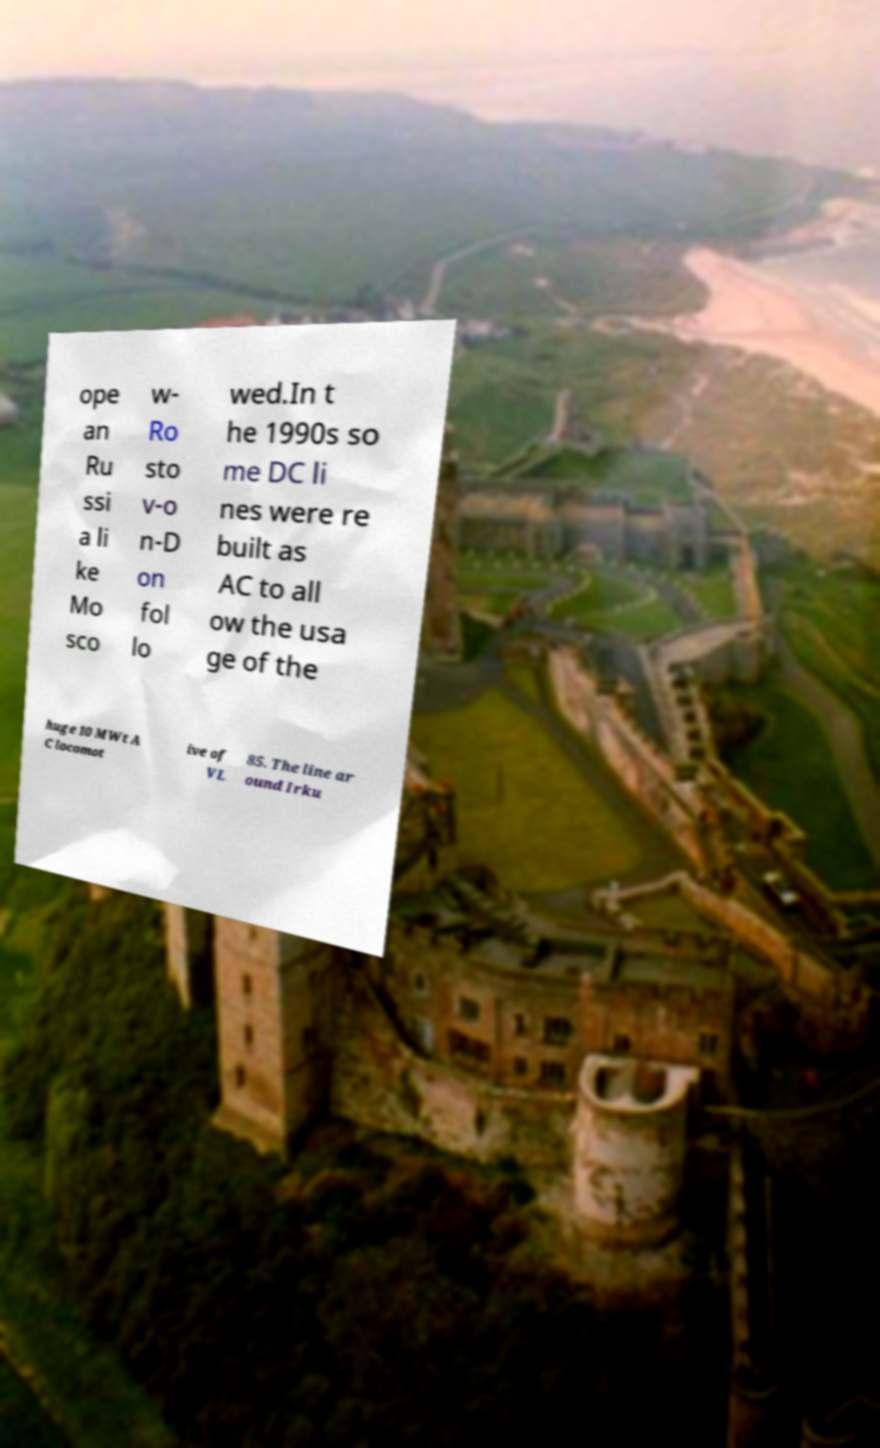Please identify and transcribe the text found in this image. ope an Ru ssi a li ke Mo sco w- Ro sto v-o n-D on fol lo wed.In t he 1990s so me DC li nes were re built as AC to all ow the usa ge of the huge 10 MWt A C locomot ive of VL 85. The line ar ound Irku 